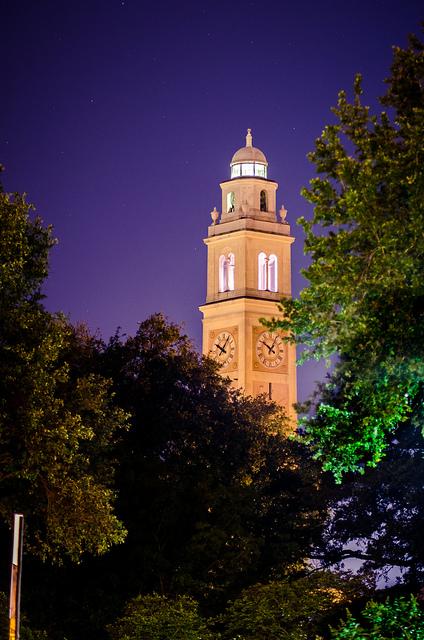Is this a church?
Quick response, please. Yes. What color is the clock tower in this photo?
Write a very short answer. Brown. What time is on the clock?
Be succinct. 10:05. Does this tower have a clock in it?
Short answer required. Yes. Is this night time?
Answer briefly. Yes. Is it a sunny day?
Answer briefly. No. How is the tree?
Give a very brief answer. Leafy. What time of day was this photo taken?
Answer briefly. Night. Is there a clock in the photo?
Write a very short answer. Yes. What color is the dome of the building?
Answer briefly. Tan. How many clock faces do you see?
Answer briefly. 2. Is the building old?
Write a very short answer. Yes. Is the tree or tower taller?
Short answer required. Tower. Is the moon present?
Short answer required. No. Is it midnight?
Quick response, please. No. What time is it on the clock in this photo?
Write a very short answer. 10:05. Is it night or day?
Concise answer only. Night. Where is the clock tower?
Write a very short answer. Behind trees. Is it daytime?
Short answer required. No. 